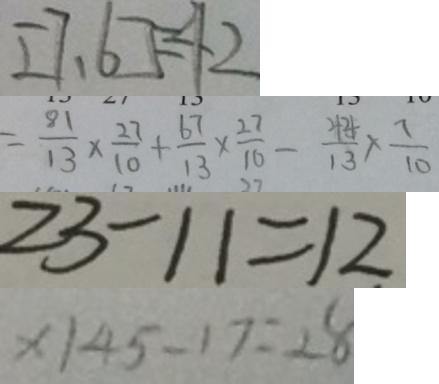<formula> <loc_0><loc_0><loc_500><loc_500>[ 7 , 6 ] = 4 2 
 = \frac { 8 1 } { 1 3 } \times \frac { 2 7 } { 1 0 } + \frac { 6 7 } { 1 3 } \times \frac { 2 7 } { 1 0 } - \frac { 4 4 } { 1 3 } \times \frac { 7 } { 1 0 } 
 2 3 - 1 1 = 1 2 
 x \vert 4 5 - 1 7 = 2 8</formula> 